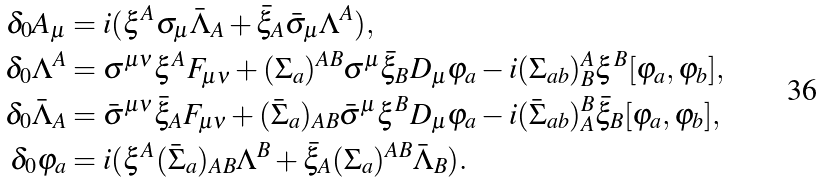Convert formula to latex. <formula><loc_0><loc_0><loc_500><loc_500>\delta _ { 0 } A _ { \mu } & = i ( \xi ^ { A } \sigma _ { \mu } \bar { \Lambda } _ { A } + \bar { \xi } _ { A } \bar { \sigma } _ { \mu } \Lambda ^ { A } ) , \\ \delta _ { 0 } \Lambda ^ { A } & = \sigma ^ { \mu \nu } \xi ^ { A } F _ { \mu \nu } + ( \Sigma _ { a } ) ^ { A B } \sigma ^ { \mu } \bar { \xi } _ { B } D _ { \mu } \varphi _ { a } - i ( \Sigma _ { a b } ) ^ { A } _ { B } \xi ^ { B } [ \varphi _ { a } , \varphi _ { b } ] , \\ \delta _ { 0 } \bar { \Lambda } _ { A } & = \bar { \sigma } ^ { \mu \nu } \bar { \xi } _ { A } F _ { \mu \nu } + ( \bar { \Sigma } _ { a } ) _ { A B } \bar { \sigma } ^ { \mu } \xi ^ { B } D _ { \mu } \varphi _ { a } - i ( \bar { \Sigma } _ { a b } ) _ { A } ^ { B } \bar { \xi } _ { B } [ \varphi _ { a } , \varphi _ { b } ] , \\ \delta _ { 0 } \varphi _ { a } & = i ( \xi ^ { A } ( \bar { \Sigma } _ { a } ) _ { A B } \Lambda ^ { B } + \bar { \xi } _ { A } ( \Sigma _ { a } ) ^ { A B } \bar { \Lambda } _ { B } ) .</formula> 